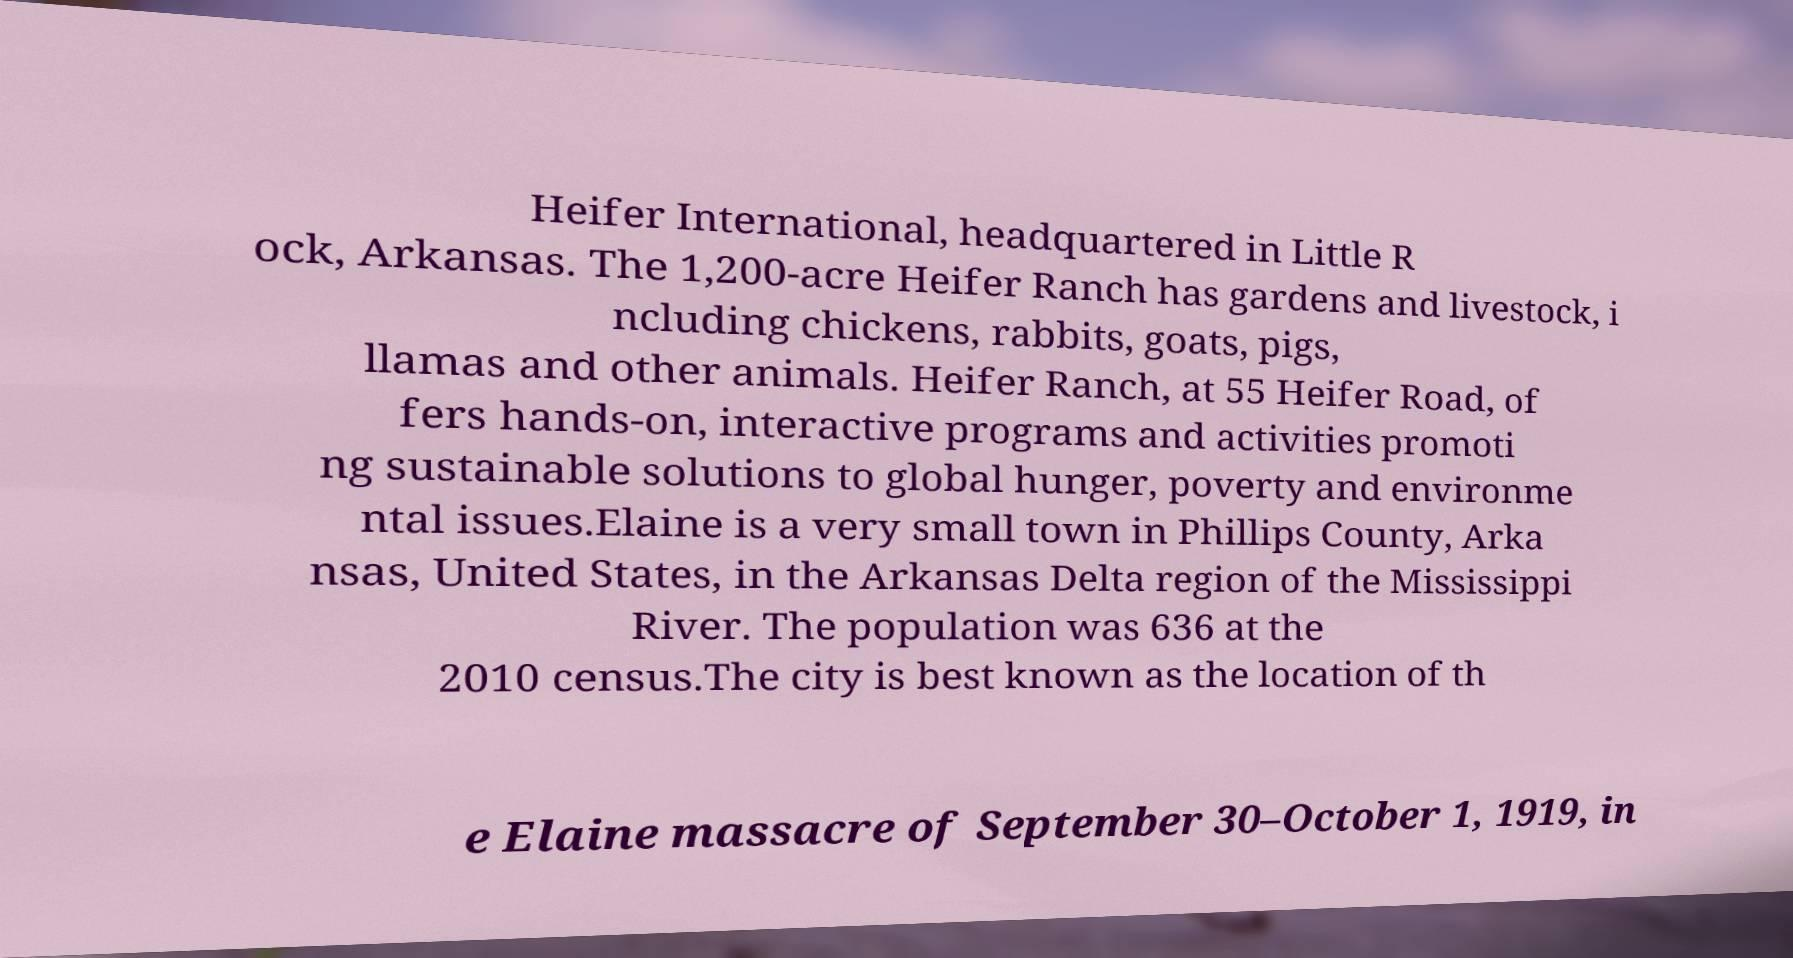I need the written content from this picture converted into text. Can you do that? Heifer International, headquartered in Little R ock, Arkansas. The 1,200-acre Heifer Ranch has gardens and livestock, i ncluding chickens, rabbits, goats, pigs, llamas and other animals. Heifer Ranch, at 55 Heifer Road, of fers hands-on, interactive programs and activities promoti ng sustainable solutions to global hunger, poverty and environme ntal issues.Elaine is a very small town in Phillips County, Arka nsas, United States, in the Arkansas Delta region of the Mississippi River. The population was 636 at the 2010 census.The city is best known as the location of th e Elaine massacre of September 30–October 1, 1919, in 